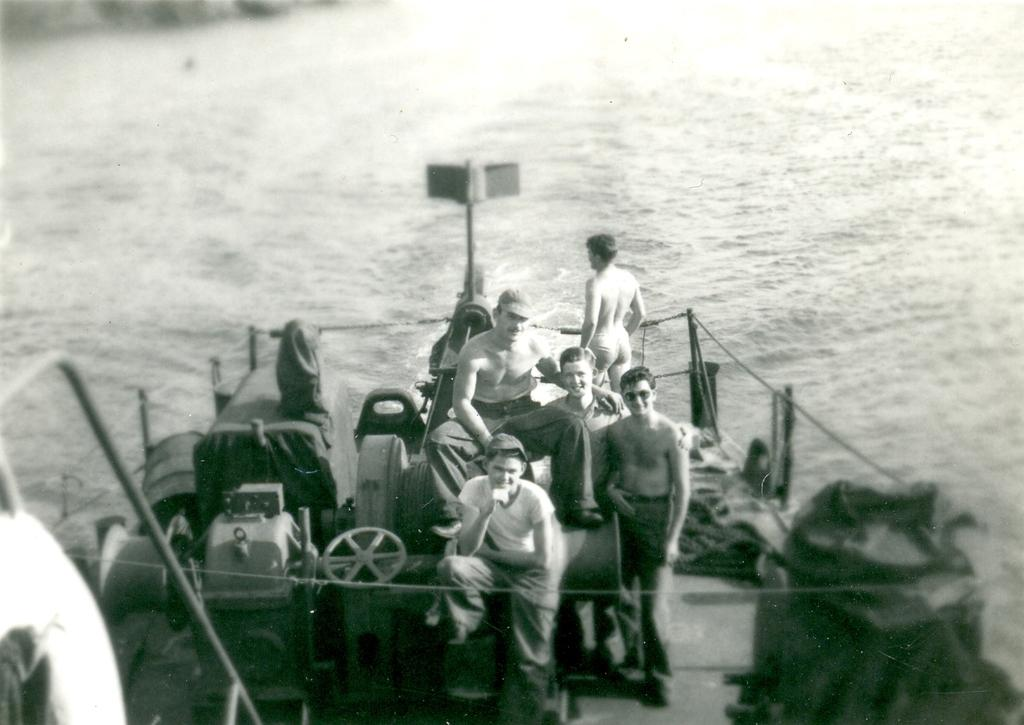What is the color scheme of the image? The image is black and white. What can be seen inside the ship in the image? There are people sitting inside the ship. What is located on the left side of the ship? There is a vehicle on the left side of the ship. How many knees can be seen in the image? There is no specific mention of knees in the image, so it is not possible to determine the number of knees present. 